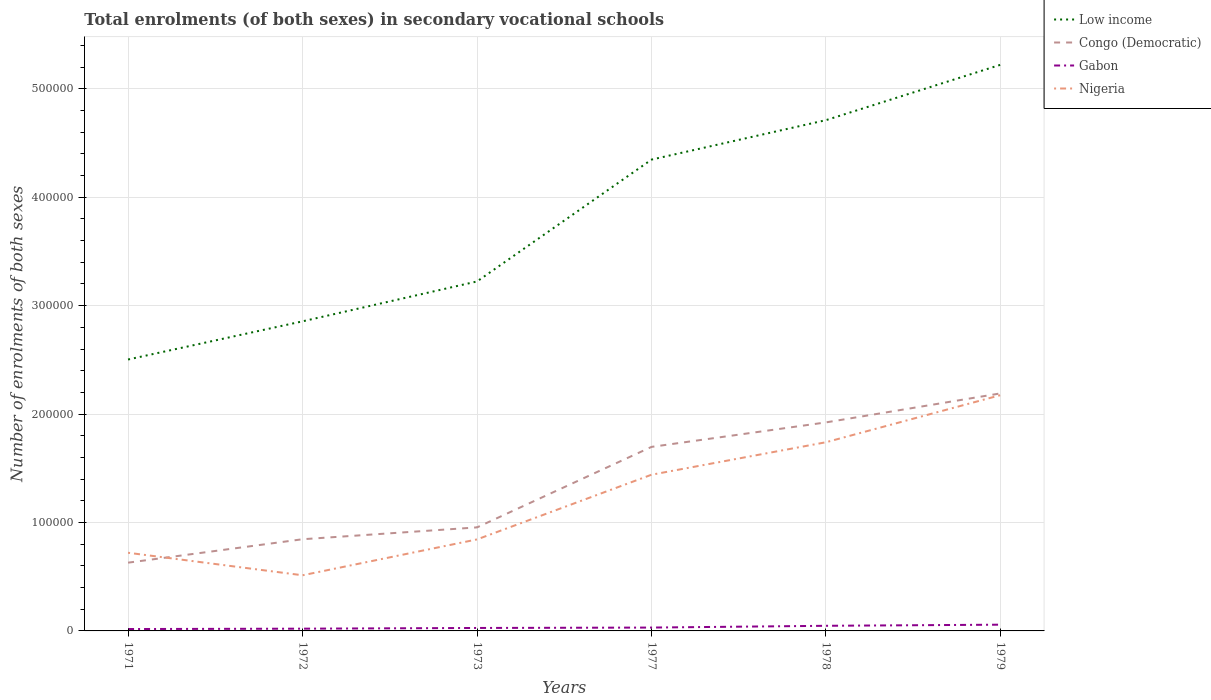Is the number of lines equal to the number of legend labels?
Your answer should be compact. Yes. Across all years, what is the maximum number of enrolments in secondary schools in Gabon?
Offer a terse response. 1739. In which year was the number of enrolments in secondary schools in Low income maximum?
Offer a terse response. 1971. What is the total number of enrolments in secondary schools in Low income in the graph?
Keep it short and to the point. -7.20e+04. What is the difference between the highest and the second highest number of enrolments in secondary schools in Nigeria?
Make the answer very short. 1.66e+05. What is the difference between the highest and the lowest number of enrolments in secondary schools in Low income?
Make the answer very short. 3. Are the values on the major ticks of Y-axis written in scientific E-notation?
Make the answer very short. No. Where does the legend appear in the graph?
Provide a short and direct response. Top right. How many legend labels are there?
Offer a very short reply. 4. What is the title of the graph?
Your response must be concise. Total enrolments (of both sexes) in secondary vocational schools. What is the label or title of the Y-axis?
Keep it short and to the point. Number of enrolments of both sexes. What is the Number of enrolments of both sexes in Low income in 1971?
Give a very brief answer. 2.50e+05. What is the Number of enrolments of both sexes in Congo (Democratic) in 1971?
Provide a succinct answer. 6.29e+04. What is the Number of enrolments of both sexes in Gabon in 1971?
Provide a short and direct response. 1739. What is the Number of enrolments of both sexes in Nigeria in 1971?
Your answer should be compact. 7.21e+04. What is the Number of enrolments of both sexes of Low income in 1972?
Provide a succinct answer. 2.86e+05. What is the Number of enrolments of both sexes of Congo (Democratic) in 1972?
Your answer should be compact. 8.46e+04. What is the Number of enrolments of both sexes in Gabon in 1972?
Keep it short and to the point. 2074. What is the Number of enrolments of both sexes in Nigeria in 1972?
Keep it short and to the point. 5.13e+04. What is the Number of enrolments of both sexes of Low income in 1973?
Your response must be concise. 3.22e+05. What is the Number of enrolments of both sexes in Congo (Democratic) in 1973?
Provide a short and direct response. 9.55e+04. What is the Number of enrolments of both sexes in Gabon in 1973?
Offer a terse response. 2725. What is the Number of enrolments of both sexes of Nigeria in 1973?
Offer a very short reply. 8.44e+04. What is the Number of enrolments of both sexes of Low income in 1977?
Provide a succinct answer. 4.35e+05. What is the Number of enrolments of both sexes of Congo (Democratic) in 1977?
Make the answer very short. 1.70e+05. What is the Number of enrolments of both sexes in Gabon in 1977?
Your answer should be compact. 3093. What is the Number of enrolments of both sexes of Nigeria in 1977?
Offer a very short reply. 1.44e+05. What is the Number of enrolments of both sexes in Low income in 1978?
Your answer should be compact. 4.71e+05. What is the Number of enrolments of both sexes in Congo (Democratic) in 1978?
Provide a succinct answer. 1.92e+05. What is the Number of enrolments of both sexes in Gabon in 1978?
Make the answer very short. 4728. What is the Number of enrolments of both sexes in Nigeria in 1978?
Keep it short and to the point. 1.74e+05. What is the Number of enrolments of both sexes of Low income in 1979?
Provide a short and direct response. 5.22e+05. What is the Number of enrolments of both sexes of Congo (Democratic) in 1979?
Ensure brevity in your answer.  2.19e+05. What is the Number of enrolments of both sexes of Gabon in 1979?
Offer a terse response. 5759. What is the Number of enrolments of both sexes in Nigeria in 1979?
Ensure brevity in your answer.  2.17e+05. Across all years, what is the maximum Number of enrolments of both sexes of Low income?
Your response must be concise. 5.22e+05. Across all years, what is the maximum Number of enrolments of both sexes in Congo (Democratic)?
Keep it short and to the point. 2.19e+05. Across all years, what is the maximum Number of enrolments of both sexes in Gabon?
Offer a terse response. 5759. Across all years, what is the maximum Number of enrolments of both sexes in Nigeria?
Ensure brevity in your answer.  2.17e+05. Across all years, what is the minimum Number of enrolments of both sexes of Low income?
Offer a terse response. 2.50e+05. Across all years, what is the minimum Number of enrolments of both sexes of Congo (Democratic)?
Make the answer very short. 6.29e+04. Across all years, what is the minimum Number of enrolments of both sexes in Gabon?
Offer a terse response. 1739. Across all years, what is the minimum Number of enrolments of both sexes in Nigeria?
Give a very brief answer. 5.13e+04. What is the total Number of enrolments of both sexes in Low income in the graph?
Ensure brevity in your answer.  2.29e+06. What is the total Number of enrolments of both sexes of Congo (Democratic) in the graph?
Provide a succinct answer. 8.24e+05. What is the total Number of enrolments of both sexes in Gabon in the graph?
Your answer should be very brief. 2.01e+04. What is the total Number of enrolments of both sexes of Nigeria in the graph?
Ensure brevity in your answer.  7.43e+05. What is the difference between the Number of enrolments of both sexes of Low income in 1971 and that in 1972?
Offer a very short reply. -3.52e+04. What is the difference between the Number of enrolments of both sexes in Congo (Democratic) in 1971 and that in 1972?
Ensure brevity in your answer.  -2.16e+04. What is the difference between the Number of enrolments of both sexes in Gabon in 1971 and that in 1972?
Offer a terse response. -335. What is the difference between the Number of enrolments of both sexes of Nigeria in 1971 and that in 1972?
Offer a very short reply. 2.08e+04. What is the difference between the Number of enrolments of both sexes in Low income in 1971 and that in 1973?
Make the answer very short. -7.20e+04. What is the difference between the Number of enrolments of both sexes of Congo (Democratic) in 1971 and that in 1973?
Your response must be concise. -3.25e+04. What is the difference between the Number of enrolments of both sexes in Gabon in 1971 and that in 1973?
Offer a terse response. -986. What is the difference between the Number of enrolments of both sexes in Nigeria in 1971 and that in 1973?
Offer a very short reply. -1.23e+04. What is the difference between the Number of enrolments of both sexes of Low income in 1971 and that in 1977?
Offer a very short reply. -1.84e+05. What is the difference between the Number of enrolments of both sexes of Congo (Democratic) in 1971 and that in 1977?
Your answer should be very brief. -1.07e+05. What is the difference between the Number of enrolments of both sexes in Gabon in 1971 and that in 1977?
Provide a succinct answer. -1354. What is the difference between the Number of enrolments of both sexes in Nigeria in 1971 and that in 1977?
Your response must be concise. -7.20e+04. What is the difference between the Number of enrolments of both sexes of Low income in 1971 and that in 1978?
Ensure brevity in your answer.  -2.21e+05. What is the difference between the Number of enrolments of both sexes in Congo (Democratic) in 1971 and that in 1978?
Provide a succinct answer. -1.29e+05. What is the difference between the Number of enrolments of both sexes in Gabon in 1971 and that in 1978?
Offer a very short reply. -2989. What is the difference between the Number of enrolments of both sexes in Nigeria in 1971 and that in 1978?
Your answer should be very brief. -1.02e+05. What is the difference between the Number of enrolments of both sexes in Low income in 1971 and that in 1979?
Ensure brevity in your answer.  -2.72e+05. What is the difference between the Number of enrolments of both sexes in Congo (Democratic) in 1971 and that in 1979?
Make the answer very short. -1.56e+05. What is the difference between the Number of enrolments of both sexes of Gabon in 1971 and that in 1979?
Give a very brief answer. -4020. What is the difference between the Number of enrolments of both sexes in Nigeria in 1971 and that in 1979?
Give a very brief answer. -1.45e+05. What is the difference between the Number of enrolments of both sexes of Low income in 1972 and that in 1973?
Provide a succinct answer. -3.68e+04. What is the difference between the Number of enrolments of both sexes in Congo (Democratic) in 1972 and that in 1973?
Provide a succinct answer. -1.09e+04. What is the difference between the Number of enrolments of both sexes in Gabon in 1972 and that in 1973?
Offer a terse response. -651. What is the difference between the Number of enrolments of both sexes in Nigeria in 1972 and that in 1973?
Your response must be concise. -3.31e+04. What is the difference between the Number of enrolments of both sexes of Low income in 1972 and that in 1977?
Make the answer very short. -1.49e+05. What is the difference between the Number of enrolments of both sexes in Congo (Democratic) in 1972 and that in 1977?
Provide a succinct answer. -8.52e+04. What is the difference between the Number of enrolments of both sexes in Gabon in 1972 and that in 1977?
Make the answer very short. -1019. What is the difference between the Number of enrolments of both sexes in Nigeria in 1972 and that in 1977?
Provide a succinct answer. -9.27e+04. What is the difference between the Number of enrolments of both sexes of Low income in 1972 and that in 1978?
Provide a succinct answer. -1.86e+05. What is the difference between the Number of enrolments of both sexes in Congo (Democratic) in 1972 and that in 1978?
Offer a terse response. -1.08e+05. What is the difference between the Number of enrolments of both sexes in Gabon in 1972 and that in 1978?
Your response must be concise. -2654. What is the difference between the Number of enrolments of both sexes in Nigeria in 1972 and that in 1978?
Provide a succinct answer. -1.23e+05. What is the difference between the Number of enrolments of both sexes in Low income in 1972 and that in 1979?
Your response must be concise. -2.37e+05. What is the difference between the Number of enrolments of both sexes in Congo (Democratic) in 1972 and that in 1979?
Your answer should be very brief. -1.35e+05. What is the difference between the Number of enrolments of both sexes of Gabon in 1972 and that in 1979?
Offer a terse response. -3685. What is the difference between the Number of enrolments of both sexes of Nigeria in 1972 and that in 1979?
Ensure brevity in your answer.  -1.66e+05. What is the difference between the Number of enrolments of both sexes of Low income in 1973 and that in 1977?
Provide a succinct answer. -1.12e+05. What is the difference between the Number of enrolments of both sexes of Congo (Democratic) in 1973 and that in 1977?
Make the answer very short. -7.42e+04. What is the difference between the Number of enrolments of both sexes of Gabon in 1973 and that in 1977?
Your answer should be very brief. -368. What is the difference between the Number of enrolments of both sexes in Nigeria in 1973 and that in 1977?
Your answer should be very brief. -5.97e+04. What is the difference between the Number of enrolments of both sexes in Low income in 1973 and that in 1978?
Provide a succinct answer. -1.49e+05. What is the difference between the Number of enrolments of both sexes of Congo (Democratic) in 1973 and that in 1978?
Your answer should be very brief. -9.68e+04. What is the difference between the Number of enrolments of both sexes of Gabon in 1973 and that in 1978?
Offer a terse response. -2003. What is the difference between the Number of enrolments of both sexes in Nigeria in 1973 and that in 1978?
Give a very brief answer. -8.96e+04. What is the difference between the Number of enrolments of both sexes of Low income in 1973 and that in 1979?
Offer a very short reply. -2.00e+05. What is the difference between the Number of enrolments of both sexes of Congo (Democratic) in 1973 and that in 1979?
Ensure brevity in your answer.  -1.24e+05. What is the difference between the Number of enrolments of both sexes in Gabon in 1973 and that in 1979?
Give a very brief answer. -3034. What is the difference between the Number of enrolments of both sexes in Nigeria in 1973 and that in 1979?
Keep it short and to the point. -1.33e+05. What is the difference between the Number of enrolments of both sexes of Low income in 1977 and that in 1978?
Your answer should be very brief. -3.64e+04. What is the difference between the Number of enrolments of both sexes in Congo (Democratic) in 1977 and that in 1978?
Your response must be concise. -2.26e+04. What is the difference between the Number of enrolments of both sexes in Gabon in 1977 and that in 1978?
Offer a very short reply. -1635. What is the difference between the Number of enrolments of both sexes of Nigeria in 1977 and that in 1978?
Keep it short and to the point. -3.00e+04. What is the difference between the Number of enrolments of both sexes of Low income in 1977 and that in 1979?
Give a very brief answer. -8.74e+04. What is the difference between the Number of enrolments of both sexes in Congo (Democratic) in 1977 and that in 1979?
Make the answer very short. -4.93e+04. What is the difference between the Number of enrolments of both sexes of Gabon in 1977 and that in 1979?
Give a very brief answer. -2666. What is the difference between the Number of enrolments of both sexes of Nigeria in 1977 and that in 1979?
Offer a terse response. -7.34e+04. What is the difference between the Number of enrolments of both sexes in Low income in 1978 and that in 1979?
Give a very brief answer. -5.11e+04. What is the difference between the Number of enrolments of both sexes in Congo (Democratic) in 1978 and that in 1979?
Your answer should be compact. -2.68e+04. What is the difference between the Number of enrolments of both sexes in Gabon in 1978 and that in 1979?
Your answer should be very brief. -1031. What is the difference between the Number of enrolments of both sexes of Nigeria in 1978 and that in 1979?
Keep it short and to the point. -4.34e+04. What is the difference between the Number of enrolments of both sexes in Low income in 1971 and the Number of enrolments of both sexes in Congo (Democratic) in 1972?
Provide a succinct answer. 1.66e+05. What is the difference between the Number of enrolments of both sexes in Low income in 1971 and the Number of enrolments of both sexes in Gabon in 1972?
Keep it short and to the point. 2.48e+05. What is the difference between the Number of enrolments of both sexes of Low income in 1971 and the Number of enrolments of both sexes of Nigeria in 1972?
Make the answer very short. 1.99e+05. What is the difference between the Number of enrolments of both sexes in Congo (Democratic) in 1971 and the Number of enrolments of both sexes in Gabon in 1972?
Make the answer very short. 6.09e+04. What is the difference between the Number of enrolments of both sexes in Congo (Democratic) in 1971 and the Number of enrolments of both sexes in Nigeria in 1972?
Your response must be concise. 1.16e+04. What is the difference between the Number of enrolments of both sexes in Gabon in 1971 and the Number of enrolments of both sexes in Nigeria in 1972?
Your answer should be very brief. -4.96e+04. What is the difference between the Number of enrolments of both sexes in Low income in 1971 and the Number of enrolments of both sexes in Congo (Democratic) in 1973?
Keep it short and to the point. 1.55e+05. What is the difference between the Number of enrolments of both sexes in Low income in 1971 and the Number of enrolments of both sexes in Gabon in 1973?
Give a very brief answer. 2.48e+05. What is the difference between the Number of enrolments of both sexes of Low income in 1971 and the Number of enrolments of both sexes of Nigeria in 1973?
Make the answer very short. 1.66e+05. What is the difference between the Number of enrolments of both sexes in Congo (Democratic) in 1971 and the Number of enrolments of both sexes in Gabon in 1973?
Offer a very short reply. 6.02e+04. What is the difference between the Number of enrolments of both sexes in Congo (Democratic) in 1971 and the Number of enrolments of both sexes in Nigeria in 1973?
Ensure brevity in your answer.  -2.15e+04. What is the difference between the Number of enrolments of both sexes in Gabon in 1971 and the Number of enrolments of both sexes in Nigeria in 1973?
Provide a succinct answer. -8.27e+04. What is the difference between the Number of enrolments of both sexes in Low income in 1971 and the Number of enrolments of both sexes in Congo (Democratic) in 1977?
Your answer should be compact. 8.06e+04. What is the difference between the Number of enrolments of both sexes of Low income in 1971 and the Number of enrolments of both sexes of Gabon in 1977?
Make the answer very short. 2.47e+05. What is the difference between the Number of enrolments of both sexes in Low income in 1971 and the Number of enrolments of both sexes in Nigeria in 1977?
Your answer should be compact. 1.06e+05. What is the difference between the Number of enrolments of both sexes of Congo (Democratic) in 1971 and the Number of enrolments of both sexes of Gabon in 1977?
Provide a succinct answer. 5.99e+04. What is the difference between the Number of enrolments of both sexes of Congo (Democratic) in 1971 and the Number of enrolments of both sexes of Nigeria in 1977?
Your answer should be very brief. -8.11e+04. What is the difference between the Number of enrolments of both sexes in Gabon in 1971 and the Number of enrolments of both sexes in Nigeria in 1977?
Keep it short and to the point. -1.42e+05. What is the difference between the Number of enrolments of both sexes of Low income in 1971 and the Number of enrolments of both sexes of Congo (Democratic) in 1978?
Your response must be concise. 5.80e+04. What is the difference between the Number of enrolments of both sexes in Low income in 1971 and the Number of enrolments of both sexes in Gabon in 1978?
Offer a very short reply. 2.46e+05. What is the difference between the Number of enrolments of both sexes of Low income in 1971 and the Number of enrolments of both sexes of Nigeria in 1978?
Provide a succinct answer. 7.63e+04. What is the difference between the Number of enrolments of both sexes of Congo (Democratic) in 1971 and the Number of enrolments of both sexes of Gabon in 1978?
Your response must be concise. 5.82e+04. What is the difference between the Number of enrolments of both sexes of Congo (Democratic) in 1971 and the Number of enrolments of both sexes of Nigeria in 1978?
Provide a succinct answer. -1.11e+05. What is the difference between the Number of enrolments of both sexes in Gabon in 1971 and the Number of enrolments of both sexes in Nigeria in 1978?
Ensure brevity in your answer.  -1.72e+05. What is the difference between the Number of enrolments of both sexes in Low income in 1971 and the Number of enrolments of both sexes in Congo (Democratic) in 1979?
Offer a terse response. 3.13e+04. What is the difference between the Number of enrolments of both sexes of Low income in 1971 and the Number of enrolments of both sexes of Gabon in 1979?
Make the answer very short. 2.45e+05. What is the difference between the Number of enrolments of both sexes of Low income in 1971 and the Number of enrolments of both sexes of Nigeria in 1979?
Ensure brevity in your answer.  3.29e+04. What is the difference between the Number of enrolments of both sexes in Congo (Democratic) in 1971 and the Number of enrolments of both sexes in Gabon in 1979?
Make the answer very short. 5.72e+04. What is the difference between the Number of enrolments of both sexes in Congo (Democratic) in 1971 and the Number of enrolments of both sexes in Nigeria in 1979?
Your response must be concise. -1.55e+05. What is the difference between the Number of enrolments of both sexes of Gabon in 1971 and the Number of enrolments of both sexes of Nigeria in 1979?
Ensure brevity in your answer.  -2.16e+05. What is the difference between the Number of enrolments of both sexes in Low income in 1972 and the Number of enrolments of both sexes in Congo (Democratic) in 1973?
Your answer should be very brief. 1.90e+05. What is the difference between the Number of enrolments of both sexes of Low income in 1972 and the Number of enrolments of both sexes of Gabon in 1973?
Provide a succinct answer. 2.83e+05. What is the difference between the Number of enrolments of both sexes in Low income in 1972 and the Number of enrolments of both sexes in Nigeria in 1973?
Keep it short and to the point. 2.01e+05. What is the difference between the Number of enrolments of both sexes of Congo (Democratic) in 1972 and the Number of enrolments of both sexes of Gabon in 1973?
Your response must be concise. 8.18e+04. What is the difference between the Number of enrolments of both sexes in Congo (Democratic) in 1972 and the Number of enrolments of both sexes in Nigeria in 1973?
Provide a succinct answer. 163. What is the difference between the Number of enrolments of both sexes in Gabon in 1972 and the Number of enrolments of both sexes in Nigeria in 1973?
Give a very brief answer. -8.23e+04. What is the difference between the Number of enrolments of both sexes in Low income in 1972 and the Number of enrolments of both sexes in Congo (Democratic) in 1977?
Ensure brevity in your answer.  1.16e+05. What is the difference between the Number of enrolments of both sexes in Low income in 1972 and the Number of enrolments of both sexes in Gabon in 1977?
Your response must be concise. 2.82e+05. What is the difference between the Number of enrolments of both sexes of Low income in 1972 and the Number of enrolments of both sexes of Nigeria in 1977?
Your answer should be compact. 1.41e+05. What is the difference between the Number of enrolments of both sexes of Congo (Democratic) in 1972 and the Number of enrolments of both sexes of Gabon in 1977?
Make the answer very short. 8.15e+04. What is the difference between the Number of enrolments of both sexes in Congo (Democratic) in 1972 and the Number of enrolments of both sexes in Nigeria in 1977?
Keep it short and to the point. -5.95e+04. What is the difference between the Number of enrolments of both sexes of Gabon in 1972 and the Number of enrolments of both sexes of Nigeria in 1977?
Your answer should be very brief. -1.42e+05. What is the difference between the Number of enrolments of both sexes of Low income in 1972 and the Number of enrolments of both sexes of Congo (Democratic) in 1978?
Your answer should be compact. 9.32e+04. What is the difference between the Number of enrolments of both sexes in Low income in 1972 and the Number of enrolments of both sexes in Gabon in 1978?
Offer a terse response. 2.81e+05. What is the difference between the Number of enrolments of both sexes in Low income in 1972 and the Number of enrolments of both sexes in Nigeria in 1978?
Your response must be concise. 1.12e+05. What is the difference between the Number of enrolments of both sexes of Congo (Democratic) in 1972 and the Number of enrolments of both sexes of Gabon in 1978?
Keep it short and to the point. 7.98e+04. What is the difference between the Number of enrolments of both sexes in Congo (Democratic) in 1972 and the Number of enrolments of both sexes in Nigeria in 1978?
Make the answer very short. -8.95e+04. What is the difference between the Number of enrolments of both sexes of Gabon in 1972 and the Number of enrolments of both sexes of Nigeria in 1978?
Offer a terse response. -1.72e+05. What is the difference between the Number of enrolments of both sexes in Low income in 1972 and the Number of enrolments of both sexes in Congo (Democratic) in 1979?
Your response must be concise. 6.65e+04. What is the difference between the Number of enrolments of both sexes in Low income in 1972 and the Number of enrolments of both sexes in Gabon in 1979?
Your answer should be compact. 2.80e+05. What is the difference between the Number of enrolments of both sexes in Low income in 1972 and the Number of enrolments of both sexes in Nigeria in 1979?
Give a very brief answer. 6.81e+04. What is the difference between the Number of enrolments of both sexes in Congo (Democratic) in 1972 and the Number of enrolments of both sexes in Gabon in 1979?
Ensure brevity in your answer.  7.88e+04. What is the difference between the Number of enrolments of both sexes of Congo (Democratic) in 1972 and the Number of enrolments of both sexes of Nigeria in 1979?
Your response must be concise. -1.33e+05. What is the difference between the Number of enrolments of both sexes of Gabon in 1972 and the Number of enrolments of both sexes of Nigeria in 1979?
Give a very brief answer. -2.15e+05. What is the difference between the Number of enrolments of both sexes in Low income in 1973 and the Number of enrolments of both sexes in Congo (Democratic) in 1977?
Your response must be concise. 1.53e+05. What is the difference between the Number of enrolments of both sexes in Low income in 1973 and the Number of enrolments of both sexes in Gabon in 1977?
Your answer should be compact. 3.19e+05. What is the difference between the Number of enrolments of both sexes in Low income in 1973 and the Number of enrolments of both sexes in Nigeria in 1977?
Provide a succinct answer. 1.78e+05. What is the difference between the Number of enrolments of both sexes of Congo (Democratic) in 1973 and the Number of enrolments of both sexes of Gabon in 1977?
Give a very brief answer. 9.24e+04. What is the difference between the Number of enrolments of both sexes in Congo (Democratic) in 1973 and the Number of enrolments of both sexes in Nigeria in 1977?
Your answer should be very brief. -4.86e+04. What is the difference between the Number of enrolments of both sexes of Gabon in 1973 and the Number of enrolments of both sexes of Nigeria in 1977?
Ensure brevity in your answer.  -1.41e+05. What is the difference between the Number of enrolments of both sexes of Low income in 1973 and the Number of enrolments of both sexes of Congo (Democratic) in 1978?
Your response must be concise. 1.30e+05. What is the difference between the Number of enrolments of both sexes of Low income in 1973 and the Number of enrolments of both sexes of Gabon in 1978?
Keep it short and to the point. 3.18e+05. What is the difference between the Number of enrolments of both sexes in Low income in 1973 and the Number of enrolments of both sexes in Nigeria in 1978?
Your response must be concise. 1.48e+05. What is the difference between the Number of enrolments of both sexes in Congo (Democratic) in 1973 and the Number of enrolments of both sexes in Gabon in 1978?
Keep it short and to the point. 9.08e+04. What is the difference between the Number of enrolments of both sexes in Congo (Democratic) in 1973 and the Number of enrolments of both sexes in Nigeria in 1978?
Give a very brief answer. -7.85e+04. What is the difference between the Number of enrolments of both sexes of Gabon in 1973 and the Number of enrolments of both sexes of Nigeria in 1978?
Your answer should be very brief. -1.71e+05. What is the difference between the Number of enrolments of both sexes of Low income in 1973 and the Number of enrolments of both sexes of Congo (Democratic) in 1979?
Your answer should be very brief. 1.03e+05. What is the difference between the Number of enrolments of both sexes in Low income in 1973 and the Number of enrolments of both sexes in Gabon in 1979?
Ensure brevity in your answer.  3.17e+05. What is the difference between the Number of enrolments of both sexes in Low income in 1973 and the Number of enrolments of both sexes in Nigeria in 1979?
Your response must be concise. 1.05e+05. What is the difference between the Number of enrolments of both sexes of Congo (Democratic) in 1973 and the Number of enrolments of both sexes of Gabon in 1979?
Provide a short and direct response. 8.97e+04. What is the difference between the Number of enrolments of both sexes of Congo (Democratic) in 1973 and the Number of enrolments of both sexes of Nigeria in 1979?
Your answer should be compact. -1.22e+05. What is the difference between the Number of enrolments of both sexes of Gabon in 1973 and the Number of enrolments of both sexes of Nigeria in 1979?
Keep it short and to the point. -2.15e+05. What is the difference between the Number of enrolments of both sexes of Low income in 1977 and the Number of enrolments of both sexes of Congo (Democratic) in 1978?
Offer a terse response. 2.42e+05. What is the difference between the Number of enrolments of both sexes of Low income in 1977 and the Number of enrolments of both sexes of Gabon in 1978?
Your response must be concise. 4.30e+05. What is the difference between the Number of enrolments of both sexes in Low income in 1977 and the Number of enrolments of both sexes in Nigeria in 1978?
Give a very brief answer. 2.61e+05. What is the difference between the Number of enrolments of both sexes in Congo (Democratic) in 1977 and the Number of enrolments of both sexes in Gabon in 1978?
Give a very brief answer. 1.65e+05. What is the difference between the Number of enrolments of both sexes in Congo (Democratic) in 1977 and the Number of enrolments of both sexes in Nigeria in 1978?
Offer a terse response. -4299. What is the difference between the Number of enrolments of both sexes of Gabon in 1977 and the Number of enrolments of both sexes of Nigeria in 1978?
Keep it short and to the point. -1.71e+05. What is the difference between the Number of enrolments of both sexes in Low income in 1977 and the Number of enrolments of both sexes in Congo (Democratic) in 1979?
Keep it short and to the point. 2.16e+05. What is the difference between the Number of enrolments of both sexes in Low income in 1977 and the Number of enrolments of both sexes in Gabon in 1979?
Your answer should be compact. 4.29e+05. What is the difference between the Number of enrolments of both sexes in Low income in 1977 and the Number of enrolments of both sexes in Nigeria in 1979?
Your response must be concise. 2.17e+05. What is the difference between the Number of enrolments of both sexes in Congo (Democratic) in 1977 and the Number of enrolments of both sexes in Gabon in 1979?
Ensure brevity in your answer.  1.64e+05. What is the difference between the Number of enrolments of both sexes in Congo (Democratic) in 1977 and the Number of enrolments of both sexes in Nigeria in 1979?
Provide a succinct answer. -4.77e+04. What is the difference between the Number of enrolments of both sexes in Gabon in 1977 and the Number of enrolments of both sexes in Nigeria in 1979?
Provide a succinct answer. -2.14e+05. What is the difference between the Number of enrolments of both sexes in Low income in 1978 and the Number of enrolments of both sexes in Congo (Democratic) in 1979?
Provide a short and direct response. 2.52e+05. What is the difference between the Number of enrolments of both sexes in Low income in 1978 and the Number of enrolments of both sexes in Gabon in 1979?
Your response must be concise. 4.65e+05. What is the difference between the Number of enrolments of both sexes in Low income in 1978 and the Number of enrolments of both sexes in Nigeria in 1979?
Offer a terse response. 2.54e+05. What is the difference between the Number of enrolments of both sexes in Congo (Democratic) in 1978 and the Number of enrolments of both sexes in Gabon in 1979?
Offer a terse response. 1.87e+05. What is the difference between the Number of enrolments of both sexes in Congo (Democratic) in 1978 and the Number of enrolments of both sexes in Nigeria in 1979?
Keep it short and to the point. -2.51e+04. What is the difference between the Number of enrolments of both sexes in Gabon in 1978 and the Number of enrolments of both sexes in Nigeria in 1979?
Give a very brief answer. -2.13e+05. What is the average Number of enrolments of both sexes in Low income per year?
Your response must be concise. 3.81e+05. What is the average Number of enrolments of both sexes in Congo (Democratic) per year?
Your response must be concise. 1.37e+05. What is the average Number of enrolments of both sexes of Gabon per year?
Ensure brevity in your answer.  3353. What is the average Number of enrolments of both sexes in Nigeria per year?
Provide a short and direct response. 1.24e+05. In the year 1971, what is the difference between the Number of enrolments of both sexes in Low income and Number of enrolments of both sexes in Congo (Democratic)?
Your response must be concise. 1.87e+05. In the year 1971, what is the difference between the Number of enrolments of both sexes in Low income and Number of enrolments of both sexes in Gabon?
Your response must be concise. 2.49e+05. In the year 1971, what is the difference between the Number of enrolments of both sexes of Low income and Number of enrolments of both sexes of Nigeria?
Make the answer very short. 1.78e+05. In the year 1971, what is the difference between the Number of enrolments of both sexes in Congo (Democratic) and Number of enrolments of both sexes in Gabon?
Make the answer very short. 6.12e+04. In the year 1971, what is the difference between the Number of enrolments of both sexes of Congo (Democratic) and Number of enrolments of both sexes of Nigeria?
Keep it short and to the point. -9145. In the year 1971, what is the difference between the Number of enrolments of both sexes of Gabon and Number of enrolments of both sexes of Nigeria?
Offer a very short reply. -7.04e+04. In the year 1972, what is the difference between the Number of enrolments of both sexes of Low income and Number of enrolments of both sexes of Congo (Democratic)?
Your response must be concise. 2.01e+05. In the year 1972, what is the difference between the Number of enrolments of both sexes of Low income and Number of enrolments of both sexes of Gabon?
Offer a terse response. 2.83e+05. In the year 1972, what is the difference between the Number of enrolments of both sexes of Low income and Number of enrolments of both sexes of Nigeria?
Your answer should be very brief. 2.34e+05. In the year 1972, what is the difference between the Number of enrolments of both sexes of Congo (Democratic) and Number of enrolments of both sexes of Gabon?
Make the answer very short. 8.25e+04. In the year 1972, what is the difference between the Number of enrolments of both sexes of Congo (Democratic) and Number of enrolments of both sexes of Nigeria?
Keep it short and to the point. 3.32e+04. In the year 1972, what is the difference between the Number of enrolments of both sexes in Gabon and Number of enrolments of both sexes in Nigeria?
Provide a short and direct response. -4.92e+04. In the year 1973, what is the difference between the Number of enrolments of both sexes of Low income and Number of enrolments of both sexes of Congo (Democratic)?
Provide a succinct answer. 2.27e+05. In the year 1973, what is the difference between the Number of enrolments of both sexes in Low income and Number of enrolments of both sexes in Gabon?
Provide a short and direct response. 3.20e+05. In the year 1973, what is the difference between the Number of enrolments of both sexes of Low income and Number of enrolments of both sexes of Nigeria?
Give a very brief answer. 2.38e+05. In the year 1973, what is the difference between the Number of enrolments of both sexes in Congo (Democratic) and Number of enrolments of both sexes in Gabon?
Offer a terse response. 9.28e+04. In the year 1973, what is the difference between the Number of enrolments of both sexes in Congo (Democratic) and Number of enrolments of both sexes in Nigeria?
Provide a short and direct response. 1.11e+04. In the year 1973, what is the difference between the Number of enrolments of both sexes in Gabon and Number of enrolments of both sexes in Nigeria?
Provide a short and direct response. -8.17e+04. In the year 1977, what is the difference between the Number of enrolments of both sexes of Low income and Number of enrolments of both sexes of Congo (Democratic)?
Your answer should be compact. 2.65e+05. In the year 1977, what is the difference between the Number of enrolments of both sexes of Low income and Number of enrolments of both sexes of Gabon?
Make the answer very short. 4.32e+05. In the year 1977, what is the difference between the Number of enrolments of both sexes in Low income and Number of enrolments of both sexes in Nigeria?
Make the answer very short. 2.91e+05. In the year 1977, what is the difference between the Number of enrolments of both sexes of Congo (Democratic) and Number of enrolments of both sexes of Gabon?
Provide a short and direct response. 1.67e+05. In the year 1977, what is the difference between the Number of enrolments of both sexes of Congo (Democratic) and Number of enrolments of both sexes of Nigeria?
Ensure brevity in your answer.  2.57e+04. In the year 1977, what is the difference between the Number of enrolments of both sexes of Gabon and Number of enrolments of both sexes of Nigeria?
Keep it short and to the point. -1.41e+05. In the year 1978, what is the difference between the Number of enrolments of both sexes in Low income and Number of enrolments of both sexes in Congo (Democratic)?
Make the answer very short. 2.79e+05. In the year 1978, what is the difference between the Number of enrolments of both sexes in Low income and Number of enrolments of both sexes in Gabon?
Your answer should be very brief. 4.66e+05. In the year 1978, what is the difference between the Number of enrolments of both sexes of Low income and Number of enrolments of both sexes of Nigeria?
Your answer should be very brief. 2.97e+05. In the year 1978, what is the difference between the Number of enrolments of both sexes of Congo (Democratic) and Number of enrolments of both sexes of Gabon?
Give a very brief answer. 1.88e+05. In the year 1978, what is the difference between the Number of enrolments of both sexes in Congo (Democratic) and Number of enrolments of both sexes in Nigeria?
Your response must be concise. 1.83e+04. In the year 1978, what is the difference between the Number of enrolments of both sexes of Gabon and Number of enrolments of both sexes of Nigeria?
Ensure brevity in your answer.  -1.69e+05. In the year 1979, what is the difference between the Number of enrolments of both sexes in Low income and Number of enrolments of both sexes in Congo (Democratic)?
Offer a terse response. 3.03e+05. In the year 1979, what is the difference between the Number of enrolments of both sexes of Low income and Number of enrolments of both sexes of Gabon?
Give a very brief answer. 5.16e+05. In the year 1979, what is the difference between the Number of enrolments of both sexes in Low income and Number of enrolments of both sexes in Nigeria?
Provide a short and direct response. 3.05e+05. In the year 1979, what is the difference between the Number of enrolments of both sexes of Congo (Democratic) and Number of enrolments of both sexes of Gabon?
Offer a very short reply. 2.13e+05. In the year 1979, what is the difference between the Number of enrolments of both sexes of Congo (Democratic) and Number of enrolments of both sexes of Nigeria?
Your answer should be compact. 1616. In the year 1979, what is the difference between the Number of enrolments of both sexes in Gabon and Number of enrolments of both sexes in Nigeria?
Give a very brief answer. -2.12e+05. What is the ratio of the Number of enrolments of both sexes of Low income in 1971 to that in 1972?
Ensure brevity in your answer.  0.88. What is the ratio of the Number of enrolments of both sexes of Congo (Democratic) in 1971 to that in 1972?
Your response must be concise. 0.74. What is the ratio of the Number of enrolments of both sexes of Gabon in 1971 to that in 1972?
Your response must be concise. 0.84. What is the ratio of the Number of enrolments of both sexes of Nigeria in 1971 to that in 1972?
Give a very brief answer. 1.4. What is the ratio of the Number of enrolments of both sexes of Low income in 1971 to that in 1973?
Your answer should be compact. 0.78. What is the ratio of the Number of enrolments of both sexes in Congo (Democratic) in 1971 to that in 1973?
Offer a terse response. 0.66. What is the ratio of the Number of enrolments of both sexes of Gabon in 1971 to that in 1973?
Offer a very short reply. 0.64. What is the ratio of the Number of enrolments of both sexes of Nigeria in 1971 to that in 1973?
Provide a short and direct response. 0.85. What is the ratio of the Number of enrolments of both sexes in Low income in 1971 to that in 1977?
Offer a terse response. 0.58. What is the ratio of the Number of enrolments of both sexes in Congo (Democratic) in 1971 to that in 1977?
Offer a very short reply. 0.37. What is the ratio of the Number of enrolments of both sexes of Gabon in 1971 to that in 1977?
Give a very brief answer. 0.56. What is the ratio of the Number of enrolments of both sexes of Nigeria in 1971 to that in 1977?
Ensure brevity in your answer.  0.5. What is the ratio of the Number of enrolments of both sexes of Low income in 1971 to that in 1978?
Ensure brevity in your answer.  0.53. What is the ratio of the Number of enrolments of both sexes in Congo (Democratic) in 1971 to that in 1978?
Give a very brief answer. 0.33. What is the ratio of the Number of enrolments of both sexes in Gabon in 1971 to that in 1978?
Your answer should be compact. 0.37. What is the ratio of the Number of enrolments of both sexes of Nigeria in 1971 to that in 1978?
Give a very brief answer. 0.41. What is the ratio of the Number of enrolments of both sexes of Low income in 1971 to that in 1979?
Offer a terse response. 0.48. What is the ratio of the Number of enrolments of both sexes of Congo (Democratic) in 1971 to that in 1979?
Keep it short and to the point. 0.29. What is the ratio of the Number of enrolments of both sexes of Gabon in 1971 to that in 1979?
Ensure brevity in your answer.  0.3. What is the ratio of the Number of enrolments of both sexes in Nigeria in 1971 to that in 1979?
Your answer should be compact. 0.33. What is the ratio of the Number of enrolments of both sexes of Low income in 1972 to that in 1973?
Make the answer very short. 0.89. What is the ratio of the Number of enrolments of both sexes of Congo (Democratic) in 1972 to that in 1973?
Provide a succinct answer. 0.89. What is the ratio of the Number of enrolments of both sexes in Gabon in 1972 to that in 1973?
Your response must be concise. 0.76. What is the ratio of the Number of enrolments of both sexes of Nigeria in 1972 to that in 1973?
Keep it short and to the point. 0.61. What is the ratio of the Number of enrolments of both sexes in Low income in 1972 to that in 1977?
Offer a very short reply. 0.66. What is the ratio of the Number of enrolments of both sexes of Congo (Democratic) in 1972 to that in 1977?
Your response must be concise. 0.5. What is the ratio of the Number of enrolments of both sexes of Gabon in 1972 to that in 1977?
Your answer should be very brief. 0.67. What is the ratio of the Number of enrolments of both sexes of Nigeria in 1972 to that in 1977?
Your answer should be very brief. 0.36. What is the ratio of the Number of enrolments of both sexes of Low income in 1972 to that in 1978?
Provide a succinct answer. 0.61. What is the ratio of the Number of enrolments of both sexes in Congo (Democratic) in 1972 to that in 1978?
Give a very brief answer. 0.44. What is the ratio of the Number of enrolments of both sexes in Gabon in 1972 to that in 1978?
Provide a succinct answer. 0.44. What is the ratio of the Number of enrolments of both sexes of Nigeria in 1972 to that in 1978?
Ensure brevity in your answer.  0.29. What is the ratio of the Number of enrolments of both sexes in Low income in 1972 to that in 1979?
Provide a succinct answer. 0.55. What is the ratio of the Number of enrolments of both sexes in Congo (Democratic) in 1972 to that in 1979?
Your answer should be compact. 0.39. What is the ratio of the Number of enrolments of both sexes of Gabon in 1972 to that in 1979?
Make the answer very short. 0.36. What is the ratio of the Number of enrolments of both sexes in Nigeria in 1972 to that in 1979?
Ensure brevity in your answer.  0.24. What is the ratio of the Number of enrolments of both sexes in Low income in 1973 to that in 1977?
Provide a short and direct response. 0.74. What is the ratio of the Number of enrolments of both sexes in Congo (Democratic) in 1973 to that in 1977?
Your response must be concise. 0.56. What is the ratio of the Number of enrolments of both sexes in Gabon in 1973 to that in 1977?
Your response must be concise. 0.88. What is the ratio of the Number of enrolments of both sexes in Nigeria in 1973 to that in 1977?
Make the answer very short. 0.59. What is the ratio of the Number of enrolments of both sexes in Low income in 1973 to that in 1978?
Offer a very short reply. 0.68. What is the ratio of the Number of enrolments of both sexes of Congo (Democratic) in 1973 to that in 1978?
Your answer should be very brief. 0.5. What is the ratio of the Number of enrolments of both sexes of Gabon in 1973 to that in 1978?
Offer a terse response. 0.58. What is the ratio of the Number of enrolments of both sexes in Nigeria in 1973 to that in 1978?
Keep it short and to the point. 0.48. What is the ratio of the Number of enrolments of both sexes of Low income in 1973 to that in 1979?
Ensure brevity in your answer.  0.62. What is the ratio of the Number of enrolments of both sexes of Congo (Democratic) in 1973 to that in 1979?
Your answer should be compact. 0.44. What is the ratio of the Number of enrolments of both sexes in Gabon in 1973 to that in 1979?
Ensure brevity in your answer.  0.47. What is the ratio of the Number of enrolments of both sexes in Nigeria in 1973 to that in 1979?
Offer a very short reply. 0.39. What is the ratio of the Number of enrolments of both sexes in Low income in 1977 to that in 1978?
Ensure brevity in your answer.  0.92. What is the ratio of the Number of enrolments of both sexes of Congo (Democratic) in 1977 to that in 1978?
Your answer should be compact. 0.88. What is the ratio of the Number of enrolments of both sexes in Gabon in 1977 to that in 1978?
Provide a short and direct response. 0.65. What is the ratio of the Number of enrolments of both sexes of Nigeria in 1977 to that in 1978?
Provide a succinct answer. 0.83. What is the ratio of the Number of enrolments of both sexes in Low income in 1977 to that in 1979?
Your response must be concise. 0.83. What is the ratio of the Number of enrolments of both sexes in Congo (Democratic) in 1977 to that in 1979?
Your answer should be very brief. 0.77. What is the ratio of the Number of enrolments of both sexes of Gabon in 1977 to that in 1979?
Provide a succinct answer. 0.54. What is the ratio of the Number of enrolments of both sexes of Nigeria in 1977 to that in 1979?
Provide a succinct answer. 0.66. What is the ratio of the Number of enrolments of both sexes of Low income in 1978 to that in 1979?
Provide a short and direct response. 0.9. What is the ratio of the Number of enrolments of both sexes of Congo (Democratic) in 1978 to that in 1979?
Provide a short and direct response. 0.88. What is the ratio of the Number of enrolments of both sexes in Gabon in 1978 to that in 1979?
Offer a very short reply. 0.82. What is the ratio of the Number of enrolments of both sexes of Nigeria in 1978 to that in 1979?
Make the answer very short. 0.8. What is the difference between the highest and the second highest Number of enrolments of both sexes in Low income?
Make the answer very short. 5.11e+04. What is the difference between the highest and the second highest Number of enrolments of both sexes of Congo (Democratic)?
Give a very brief answer. 2.68e+04. What is the difference between the highest and the second highest Number of enrolments of both sexes of Gabon?
Provide a succinct answer. 1031. What is the difference between the highest and the second highest Number of enrolments of both sexes in Nigeria?
Give a very brief answer. 4.34e+04. What is the difference between the highest and the lowest Number of enrolments of both sexes of Low income?
Offer a terse response. 2.72e+05. What is the difference between the highest and the lowest Number of enrolments of both sexes in Congo (Democratic)?
Make the answer very short. 1.56e+05. What is the difference between the highest and the lowest Number of enrolments of both sexes in Gabon?
Provide a succinct answer. 4020. What is the difference between the highest and the lowest Number of enrolments of both sexes in Nigeria?
Provide a short and direct response. 1.66e+05. 